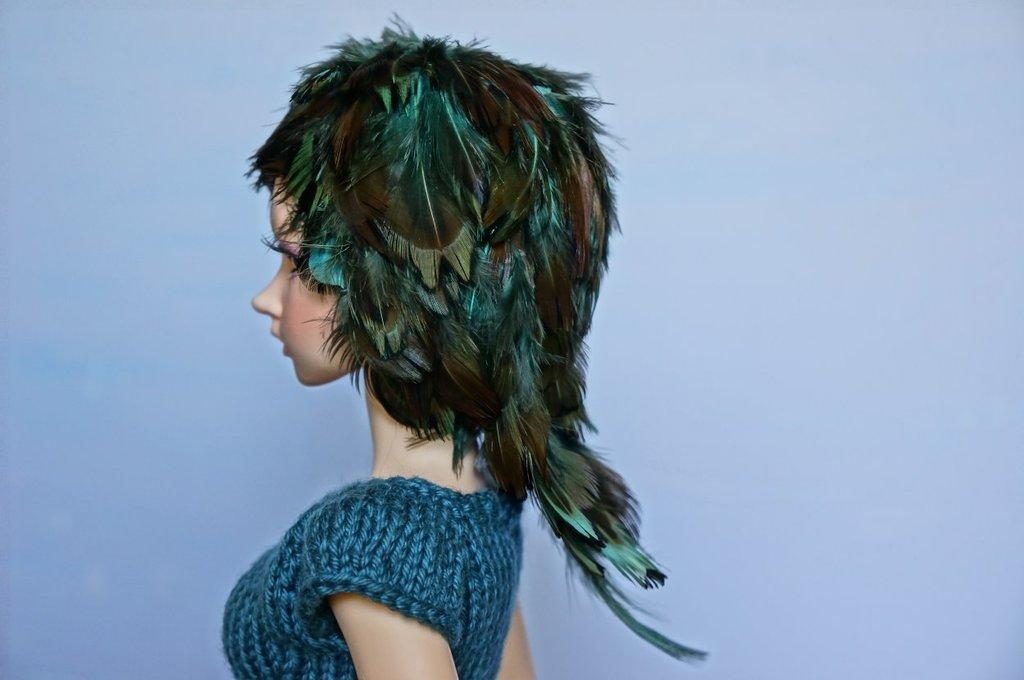What is the main subject in the foreground of the image? There is a mannequin in the foreground of the image. What is unique about the mannequin's appearance? The mannequin has a feather wig. What type of clothing is the mannequin wearing? The mannequin is wearing a blue dress. What color dominates the background of the image? The background of the image is blue. How many cherries are on the mannequin's head in the image? There are no cherries present on the mannequin's head in the image. What type of pleasure does the mannequin provide in the image? The mannequin is an inanimate object and does not provide any pleasure in the image. 